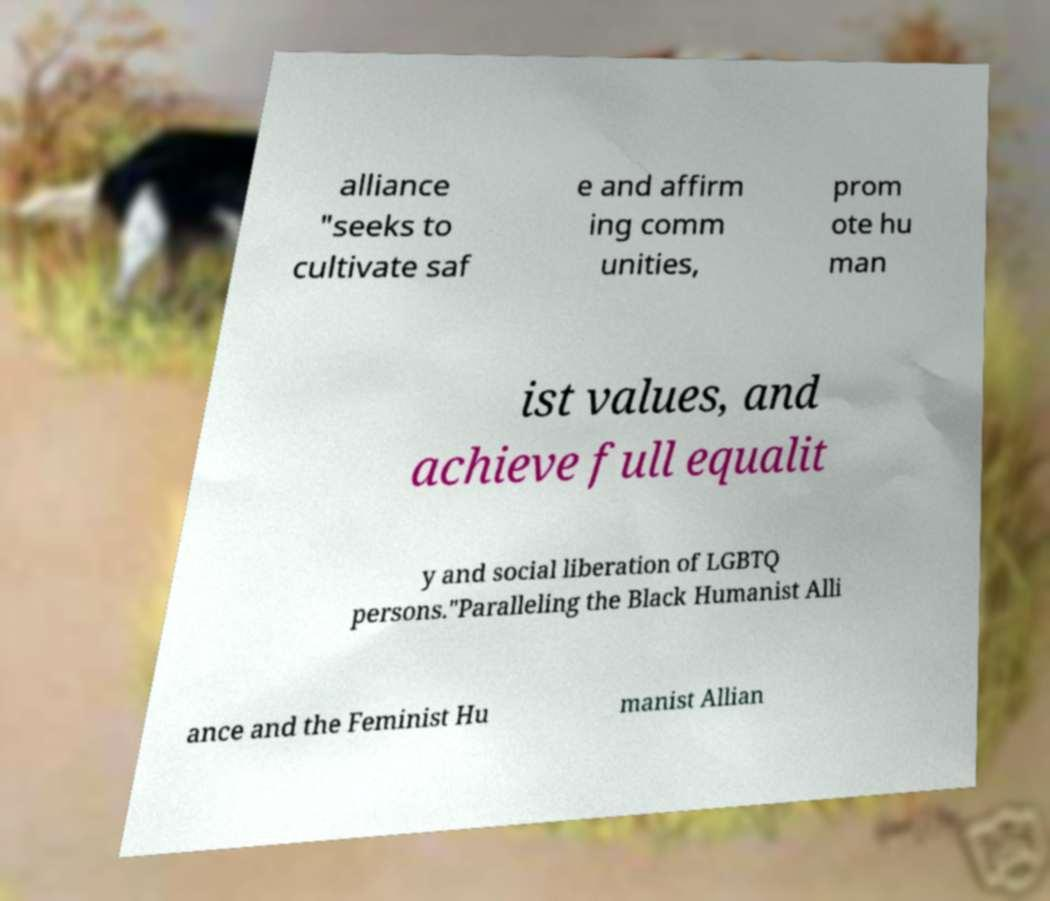Please identify and transcribe the text found in this image. alliance "seeks to cultivate saf e and affirm ing comm unities, prom ote hu man ist values, and achieve full equalit y and social liberation of LGBTQ persons."Paralleling the Black Humanist Alli ance and the Feminist Hu manist Allian 